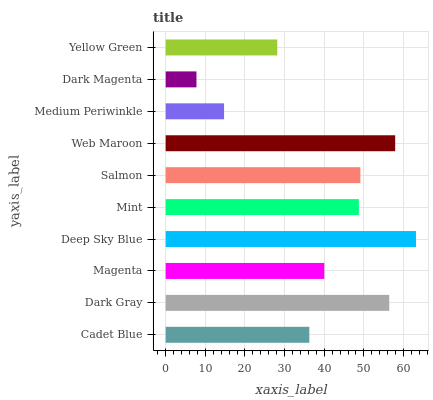Is Dark Magenta the minimum?
Answer yes or no. Yes. Is Deep Sky Blue the maximum?
Answer yes or no. Yes. Is Dark Gray the minimum?
Answer yes or no. No. Is Dark Gray the maximum?
Answer yes or no. No. Is Dark Gray greater than Cadet Blue?
Answer yes or no. Yes. Is Cadet Blue less than Dark Gray?
Answer yes or no. Yes. Is Cadet Blue greater than Dark Gray?
Answer yes or no. No. Is Dark Gray less than Cadet Blue?
Answer yes or no. No. Is Mint the high median?
Answer yes or no. Yes. Is Magenta the low median?
Answer yes or no. Yes. Is Cadet Blue the high median?
Answer yes or no. No. Is Dark Magenta the low median?
Answer yes or no. No. 